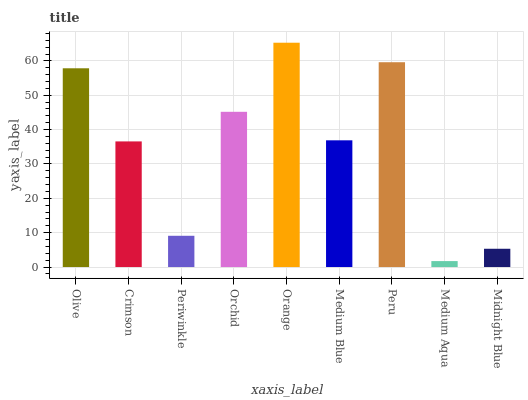Is Medium Aqua the minimum?
Answer yes or no. Yes. Is Orange the maximum?
Answer yes or no. Yes. Is Crimson the minimum?
Answer yes or no. No. Is Crimson the maximum?
Answer yes or no. No. Is Olive greater than Crimson?
Answer yes or no. Yes. Is Crimson less than Olive?
Answer yes or no. Yes. Is Crimson greater than Olive?
Answer yes or no. No. Is Olive less than Crimson?
Answer yes or no. No. Is Medium Blue the high median?
Answer yes or no. Yes. Is Medium Blue the low median?
Answer yes or no. Yes. Is Olive the high median?
Answer yes or no. No. Is Orchid the low median?
Answer yes or no. No. 